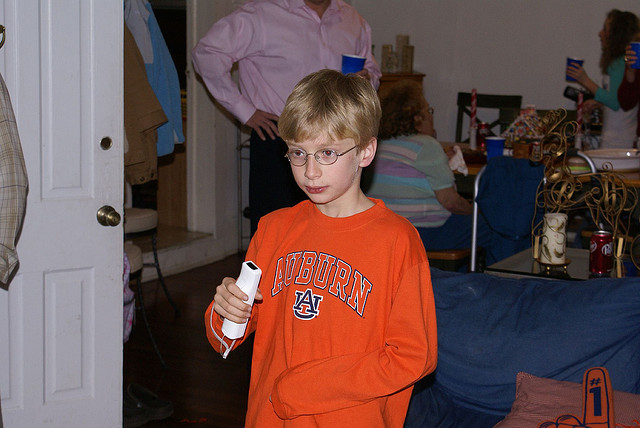Please identify all text content in this image. AUBURN IAT 1 ps 